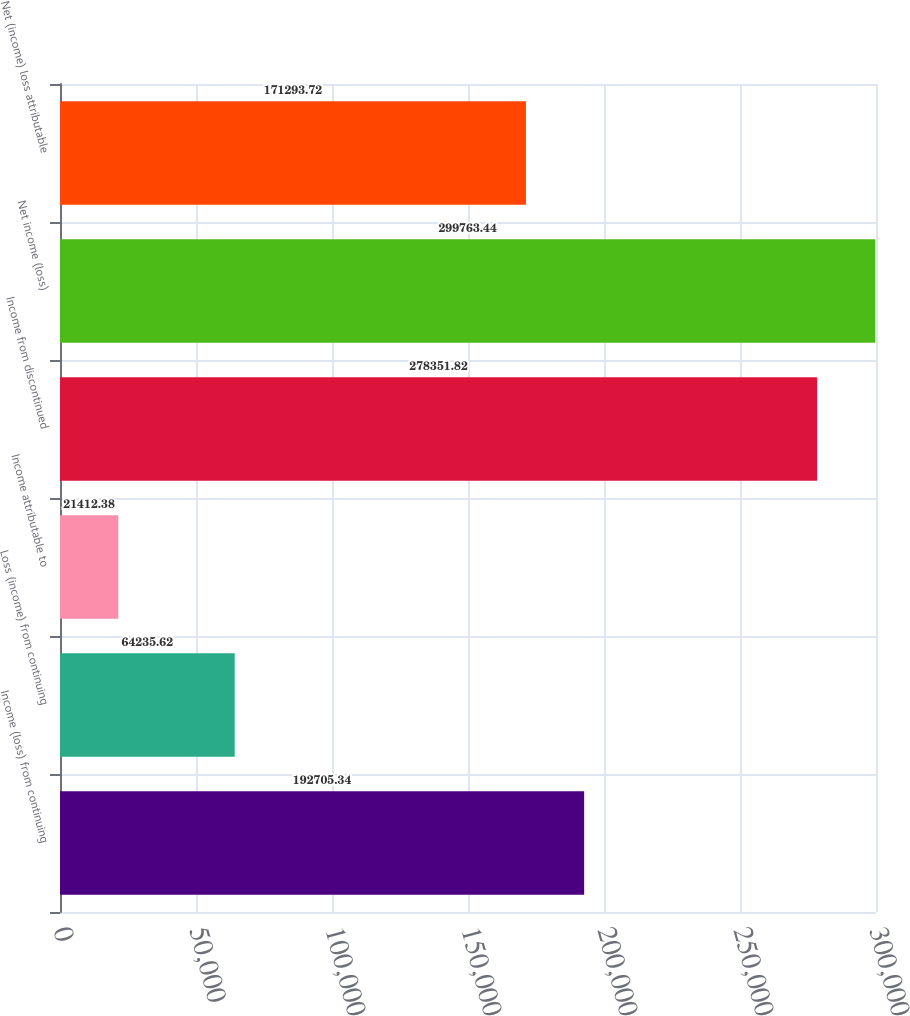<chart> <loc_0><loc_0><loc_500><loc_500><bar_chart><fcel>Income (loss) from continuing<fcel>Loss (income) from continuing<fcel>Income attributable to<fcel>Income from discontinued<fcel>Net income (loss)<fcel>Net (income) loss attributable<nl><fcel>192705<fcel>64235.6<fcel>21412.4<fcel>278352<fcel>299763<fcel>171294<nl></chart> 